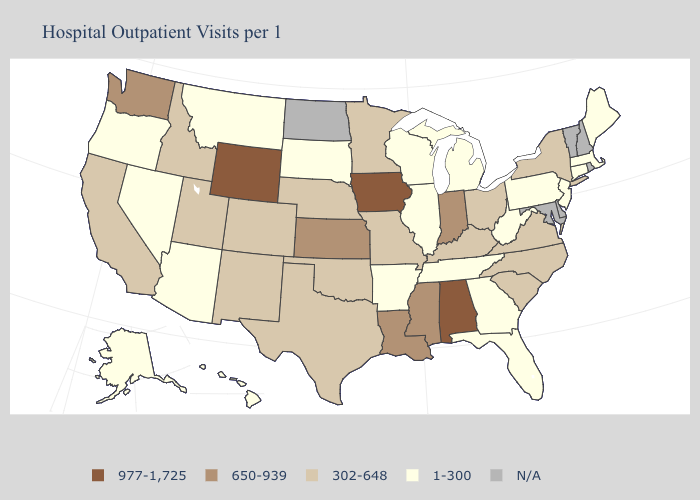Which states hav the highest value in the South?
Keep it brief. Alabama. Name the states that have a value in the range 650-939?
Keep it brief. Indiana, Kansas, Louisiana, Mississippi, Washington. Among the states that border New Mexico , does Utah have the highest value?
Write a very short answer. Yes. What is the value of Hawaii?
Answer briefly. 1-300. How many symbols are there in the legend?
Quick response, please. 5. Name the states that have a value in the range 1-300?
Short answer required. Alaska, Arizona, Arkansas, Connecticut, Florida, Georgia, Hawaii, Illinois, Maine, Massachusetts, Michigan, Montana, Nevada, New Jersey, Oregon, Pennsylvania, South Dakota, Tennessee, West Virginia, Wisconsin. What is the highest value in states that border Nevada?
Write a very short answer. 302-648. Name the states that have a value in the range 977-1,725?
Keep it brief. Alabama, Iowa, Wyoming. What is the highest value in states that border Arkansas?
Give a very brief answer. 650-939. Name the states that have a value in the range 650-939?
Answer briefly. Indiana, Kansas, Louisiana, Mississippi, Washington. What is the value of Vermont?
Keep it brief. N/A. What is the value of Nebraska?
Be succinct. 302-648. Which states have the highest value in the USA?
Quick response, please. Alabama, Iowa, Wyoming. 